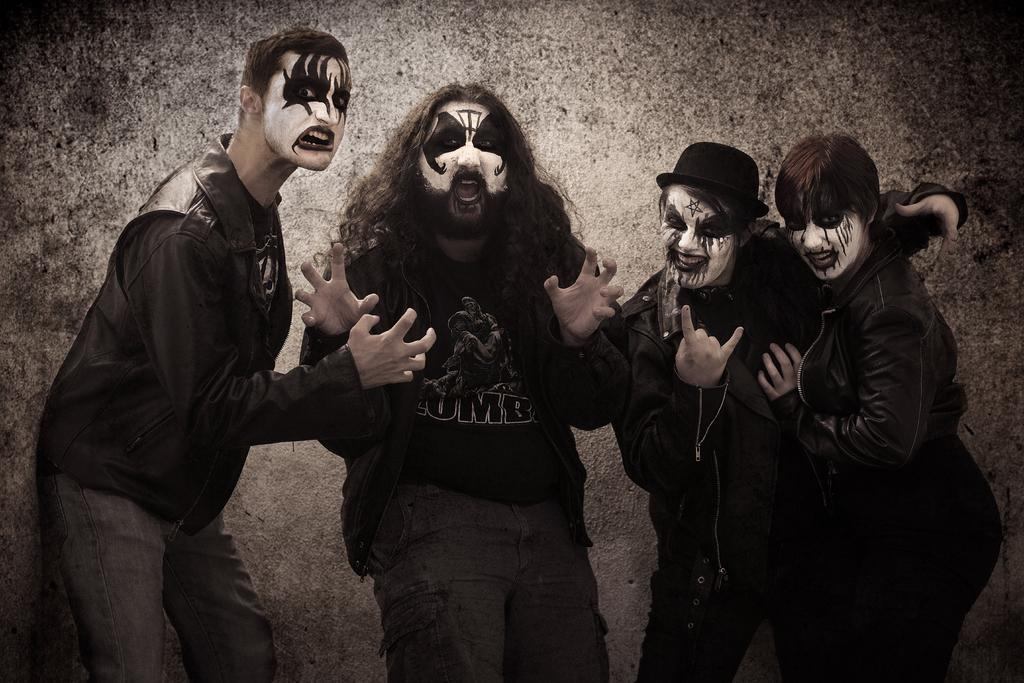What can be seen in the image? There are people standing in the image. What is unique about the people's appearance? The people have face paintings on their faces. What can be seen in the background of the image? There is a wall visible in the background of the image. What is the crowd discussing in the image? There is no crowd or discussion present in the image. 